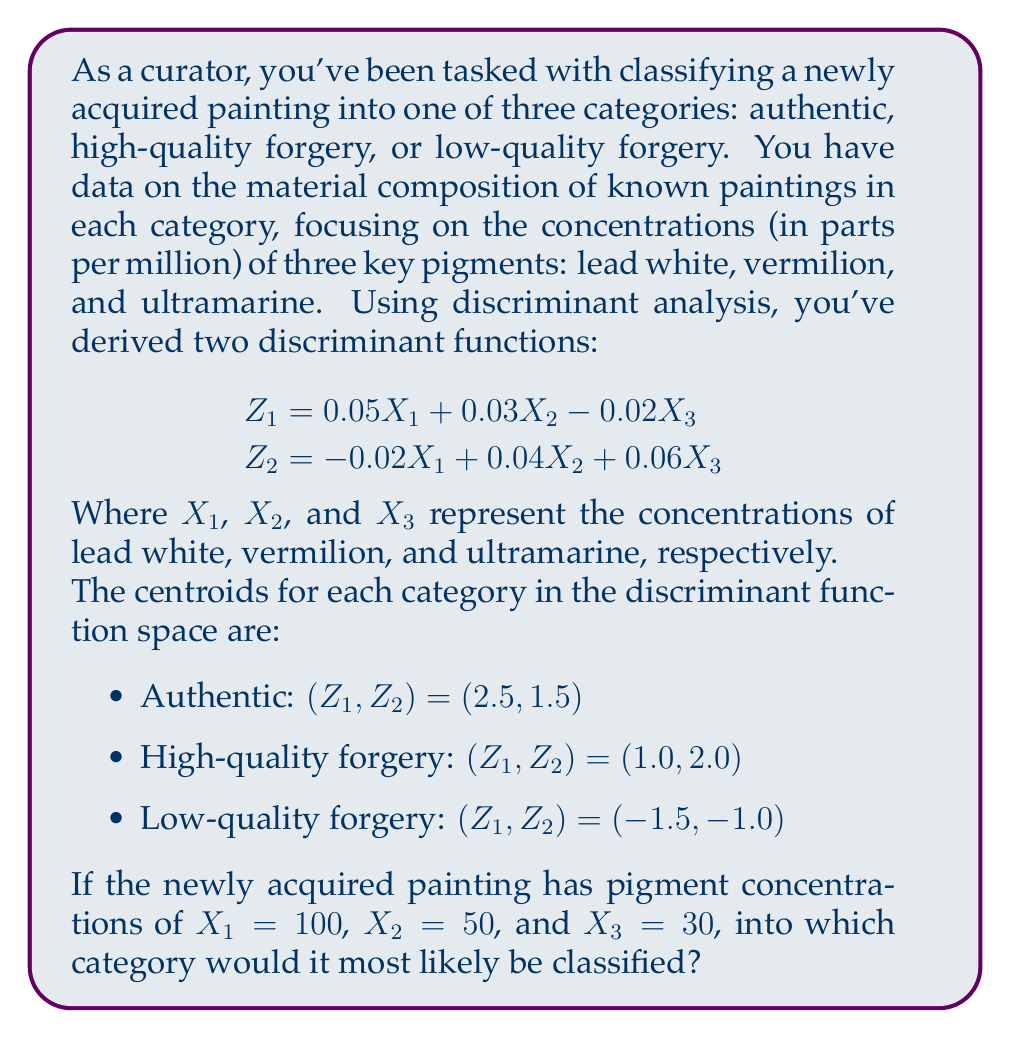Could you help me with this problem? To solve this problem, we'll follow these steps:

1. Calculate the discriminant function scores $(Z_1, Z_2)$ for the new painting using the given concentrations.

2. Calculate the Euclidean distance from the new painting's point to each category centroid in the discriminant function space.

3. Classify the painting into the category with the nearest centroid.

Step 1: Calculate $Z_1$ and $Z_2$

For $X_1 = 100$, $X_2 = 50$, and $X_3 = 30$:

$$
\begin{aligned}
Z_1 &= 0.05(100) + 0.03(50) - 0.02(30) \\
&= 5 + 1.5 - 0.6 = 5.9
\end{aligned}
$$

$$
\begin{aligned}
Z_2 &= -0.02(100) + 0.04(50) + 0.06(30) \\
&= -2 + 2 + 1.8 = 1.8
\end{aligned}
$$

The new painting's point in discriminant function space is $(5.9, 1.8)$.

Step 2: Calculate distances to centroids

Using the Euclidean distance formula $d = \sqrt{(x_2-x_1)^2 + (y_2-y_1)^2}$:

Authentic: 
$$d_1 = \sqrt{(5.9-2.5)^2 + (1.8-1.5)^2} = 3.41$$

High-quality forgery: 
$$d_2 = \sqrt{(5.9-1.0)^2 + (1.8-2.0)^2} = 4.90$$

Low-quality forgery: 
$$d_3 = \sqrt{(5.9-(-1.5))^2 + (1.8-(-1.0))^2} = 7.85$$

Step 3: Classify the painting

The smallest distance is $d_1 = 3.41$, corresponding to the authentic category.
Answer: Authentic 